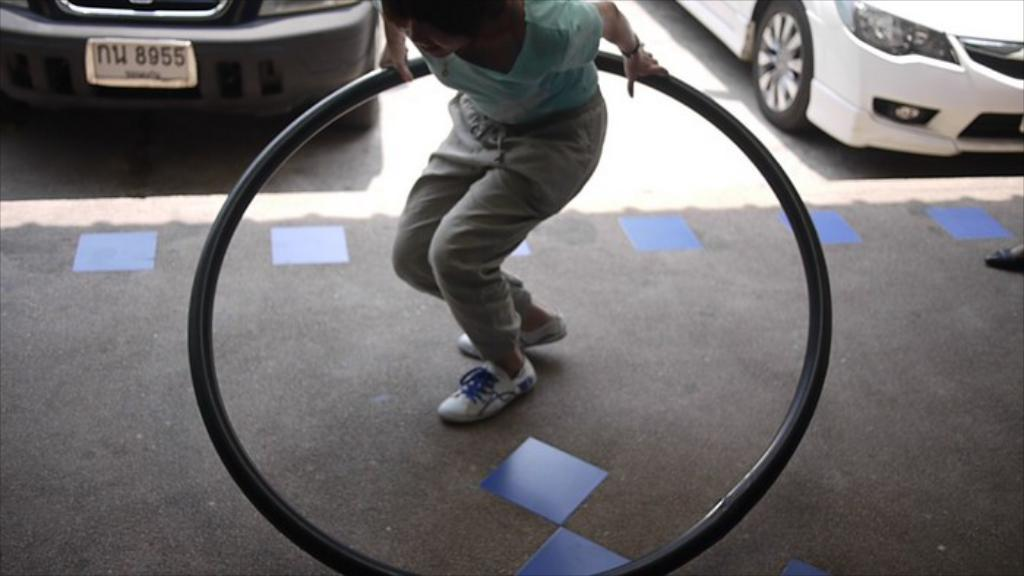What is the person in the image doing? The person is holding an exercise wheel. Can you describe the exercise equipment being used? The person is holding an exercise wheel, which is a circular device used for exercise. What else can be seen in the image besides the person and the exercise wheel? Cars are visible on a road in the image. What type of quiver is the person wearing in the image? There is no quiver present in the image; the person is holding an exercise wheel. Is the person wearing a mask in the image? There is no mention of a mask in the image; the person is holding an exercise wheel. 